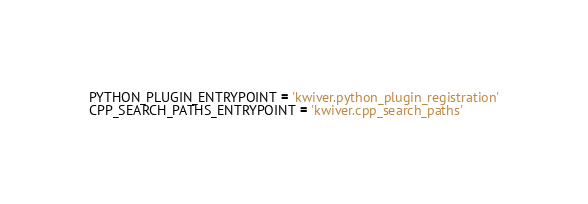Convert code to text. <code><loc_0><loc_0><loc_500><loc_500><_Python_>PYTHON_PLUGIN_ENTRYPOINT = 'kwiver.python_plugin_registration'
CPP_SEARCH_PATHS_ENTRYPOINT = 'kwiver.cpp_search_paths'
</code> 